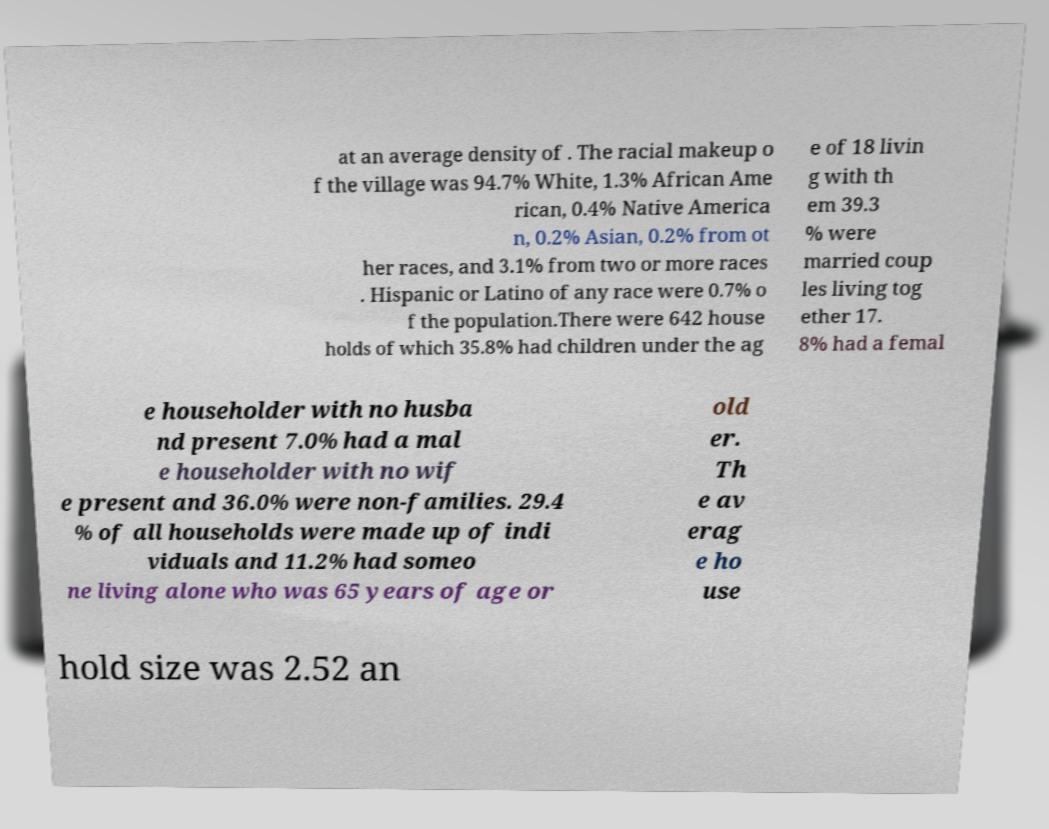I need the written content from this picture converted into text. Can you do that? at an average density of . The racial makeup o f the village was 94.7% White, 1.3% African Ame rican, 0.4% Native America n, 0.2% Asian, 0.2% from ot her races, and 3.1% from two or more races . Hispanic or Latino of any race were 0.7% o f the population.There were 642 house holds of which 35.8% had children under the ag e of 18 livin g with th em 39.3 % were married coup les living tog ether 17. 8% had a femal e householder with no husba nd present 7.0% had a mal e householder with no wif e present and 36.0% were non-families. 29.4 % of all households were made up of indi viduals and 11.2% had someo ne living alone who was 65 years of age or old er. Th e av erag e ho use hold size was 2.52 an 